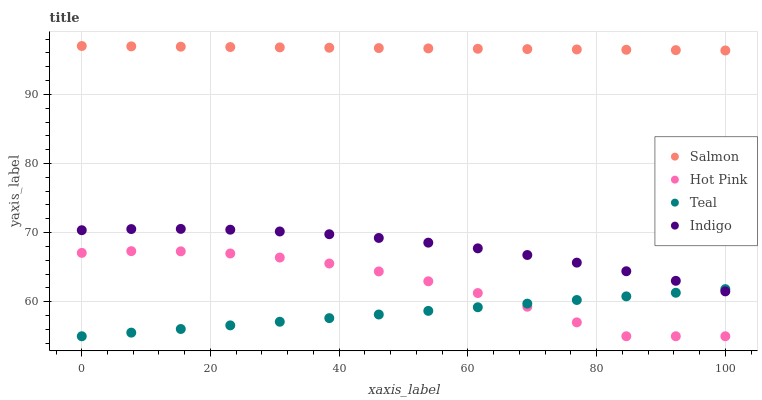Does Teal have the minimum area under the curve?
Answer yes or no. Yes. Does Salmon have the maximum area under the curve?
Answer yes or no. Yes. Does Hot Pink have the minimum area under the curve?
Answer yes or no. No. Does Hot Pink have the maximum area under the curve?
Answer yes or no. No. Is Salmon the smoothest?
Answer yes or no. Yes. Is Hot Pink the roughest?
Answer yes or no. Yes. Is Hot Pink the smoothest?
Answer yes or no. No. Is Salmon the roughest?
Answer yes or no. No. Does Hot Pink have the lowest value?
Answer yes or no. Yes. Does Salmon have the lowest value?
Answer yes or no. No. Does Salmon have the highest value?
Answer yes or no. Yes. Does Hot Pink have the highest value?
Answer yes or no. No. Is Teal less than Salmon?
Answer yes or no. Yes. Is Indigo greater than Hot Pink?
Answer yes or no. Yes. Does Teal intersect Hot Pink?
Answer yes or no. Yes. Is Teal less than Hot Pink?
Answer yes or no. No. Is Teal greater than Hot Pink?
Answer yes or no. No. Does Teal intersect Salmon?
Answer yes or no. No. 